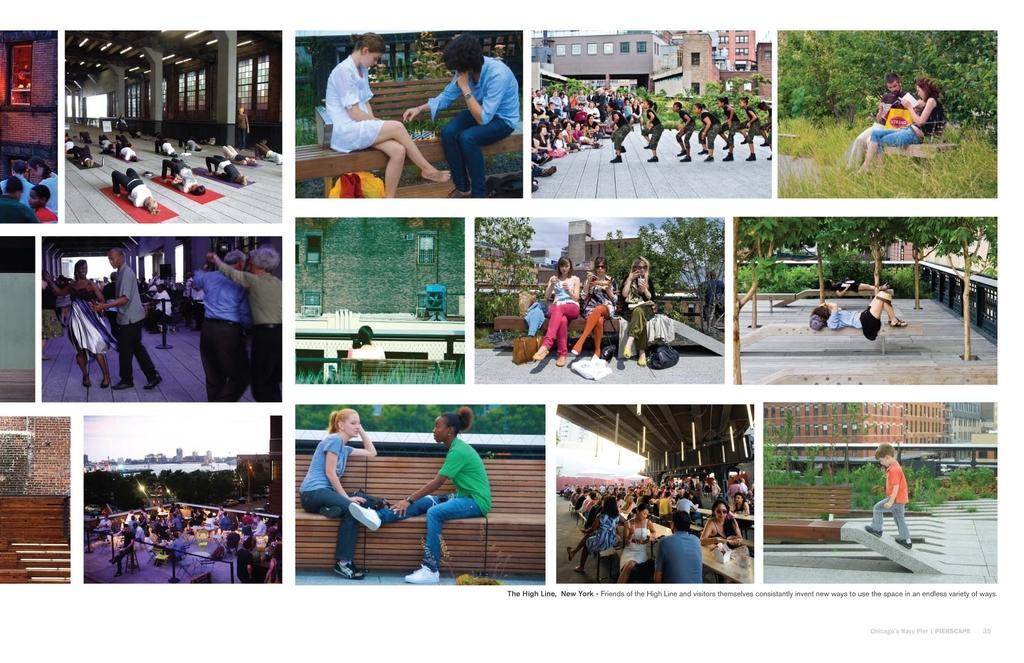In one or two sentences, can you explain what this image depicts? In this image I see collage of many pictures and I see number of people and I see that few of them are sitting, few of them are lying and rest of them are standing and I see the plants, trees, buildings, path and the sky. 